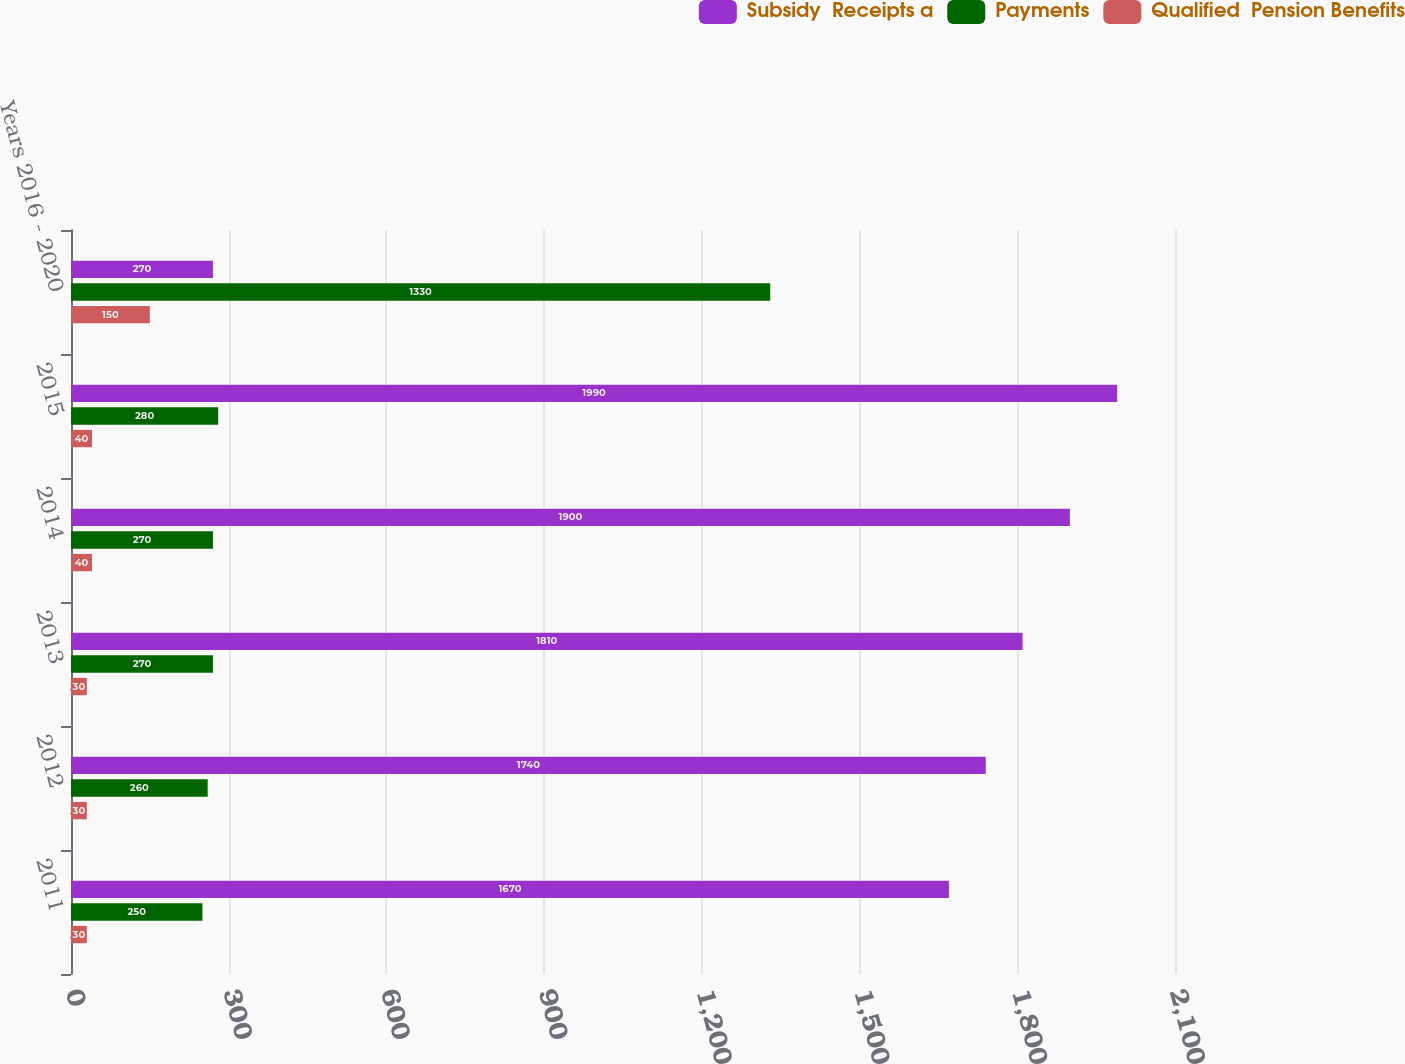<chart> <loc_0><loc_0><loc_500><loc_500><stacked_bar_chart><ecel><fcel>2011<fcel>2012<fcel>2013<fcel>2014<fcel>2015<fcel>Years 2016 - 2020<nl><fcel>Subsidy  Receipts a<fcel>1670<fcel>1740<fcel>1810<fcel>1900<fcel>1990<fcel>270<nl><fcel>Payments<fcel>250<fcel>260<fcel>270<fcel>270<fcel>280<fcel>1330<nl><fcel>Qualified  Pension Benefits<fcel>30<fcel>30<fcel>30<fcel>40<fcel>40<fcel>150<nl></chart> 